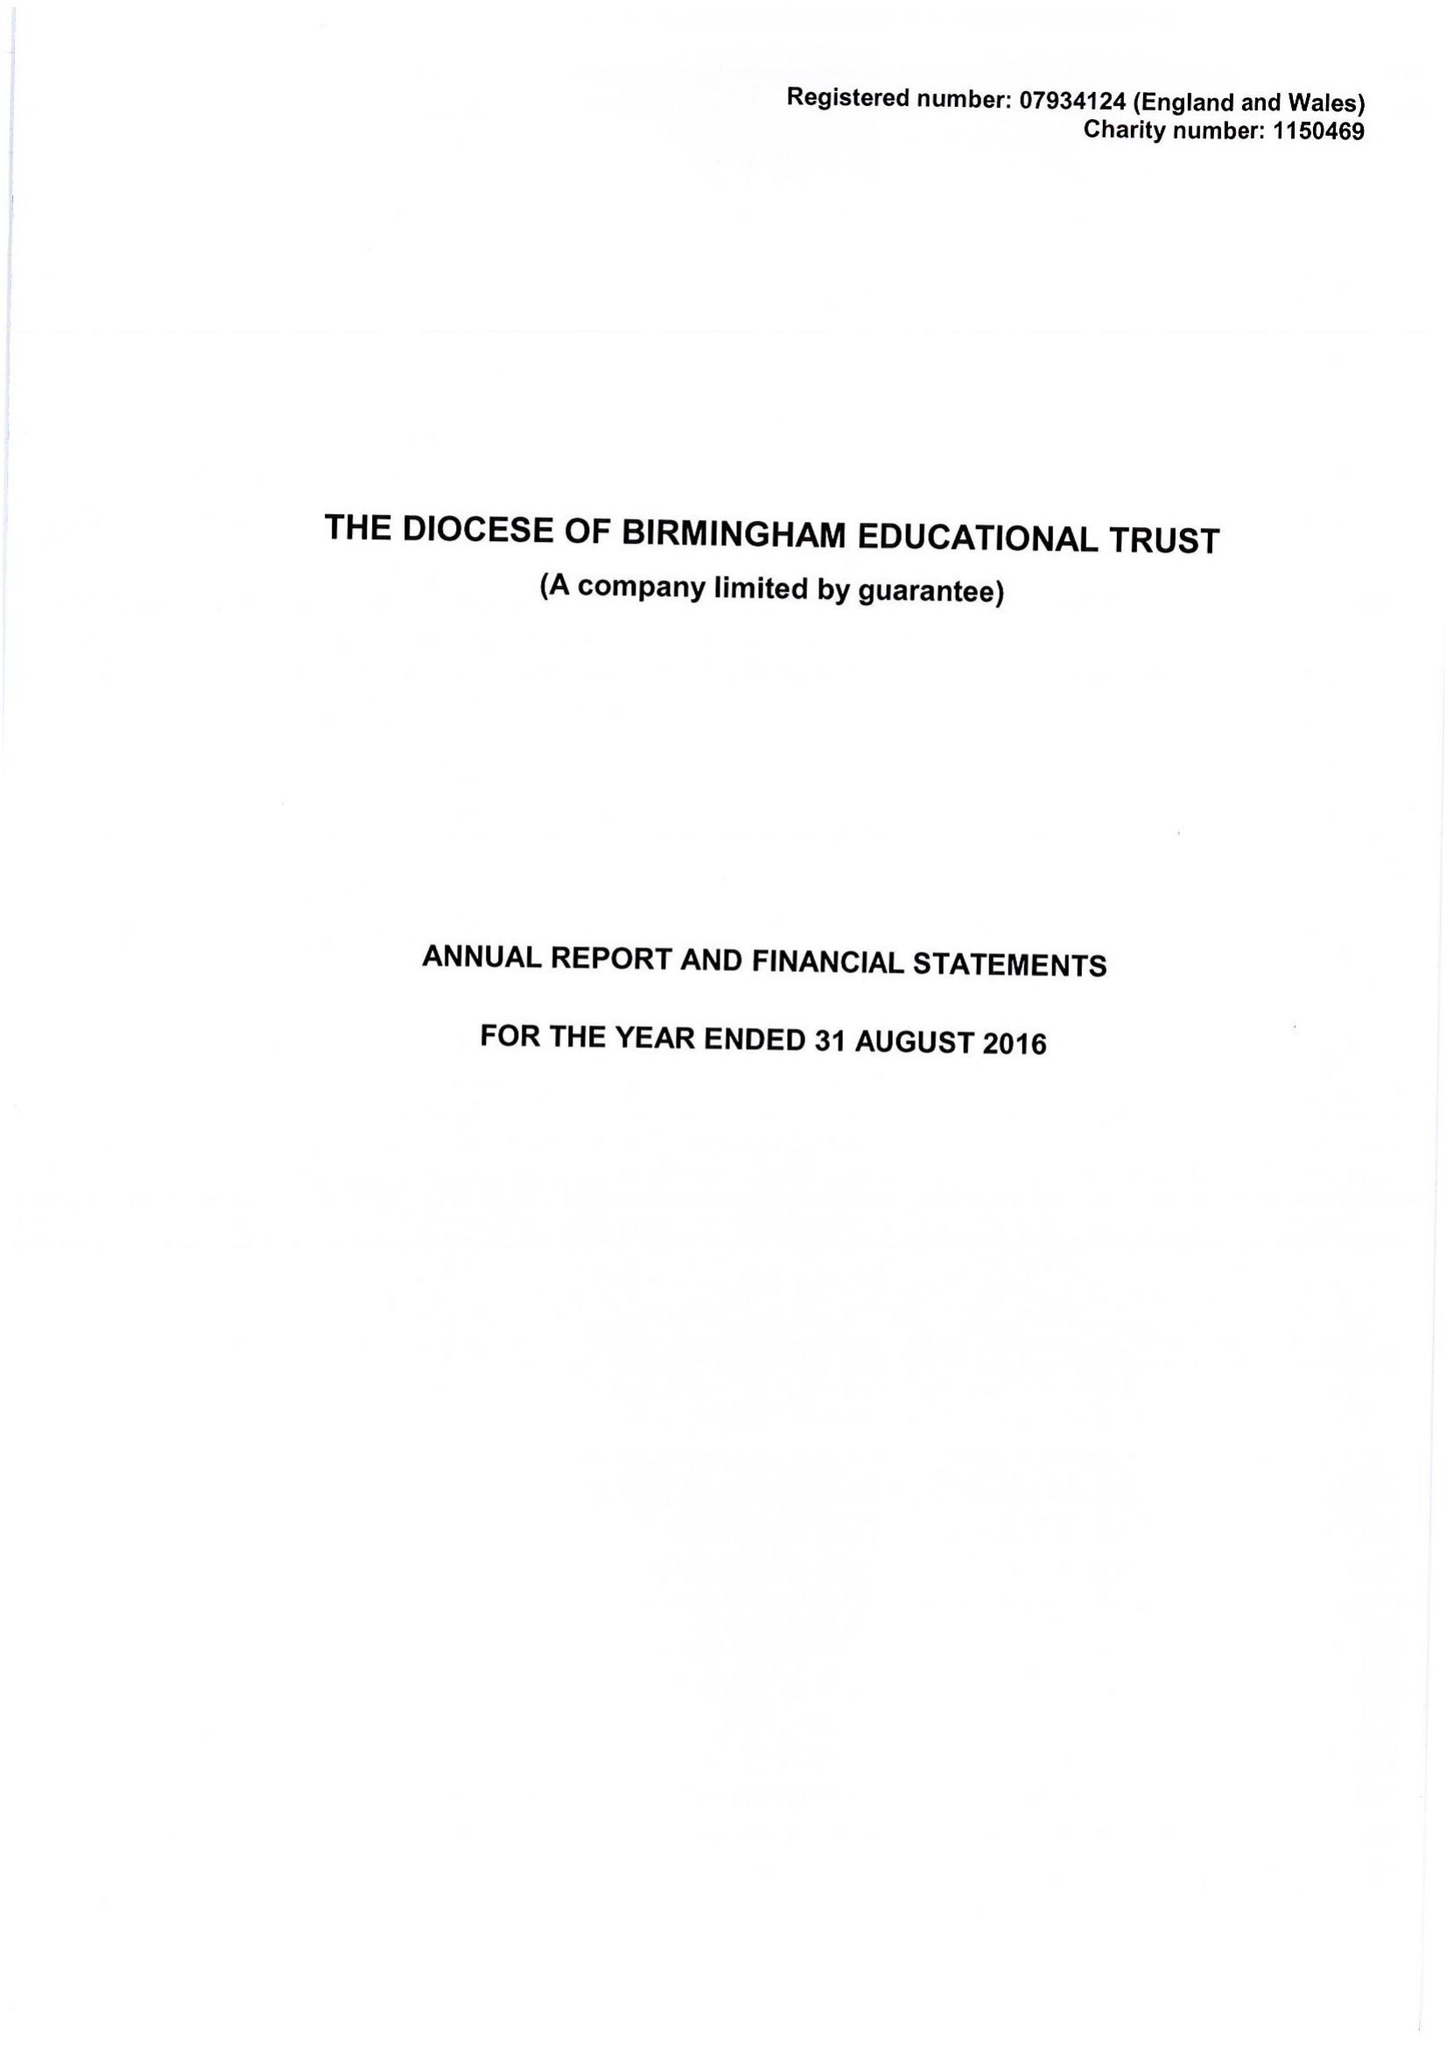What is the value for the address__street_line?
Answer the question using a single word or phrase. 1 COLMORE ROW 